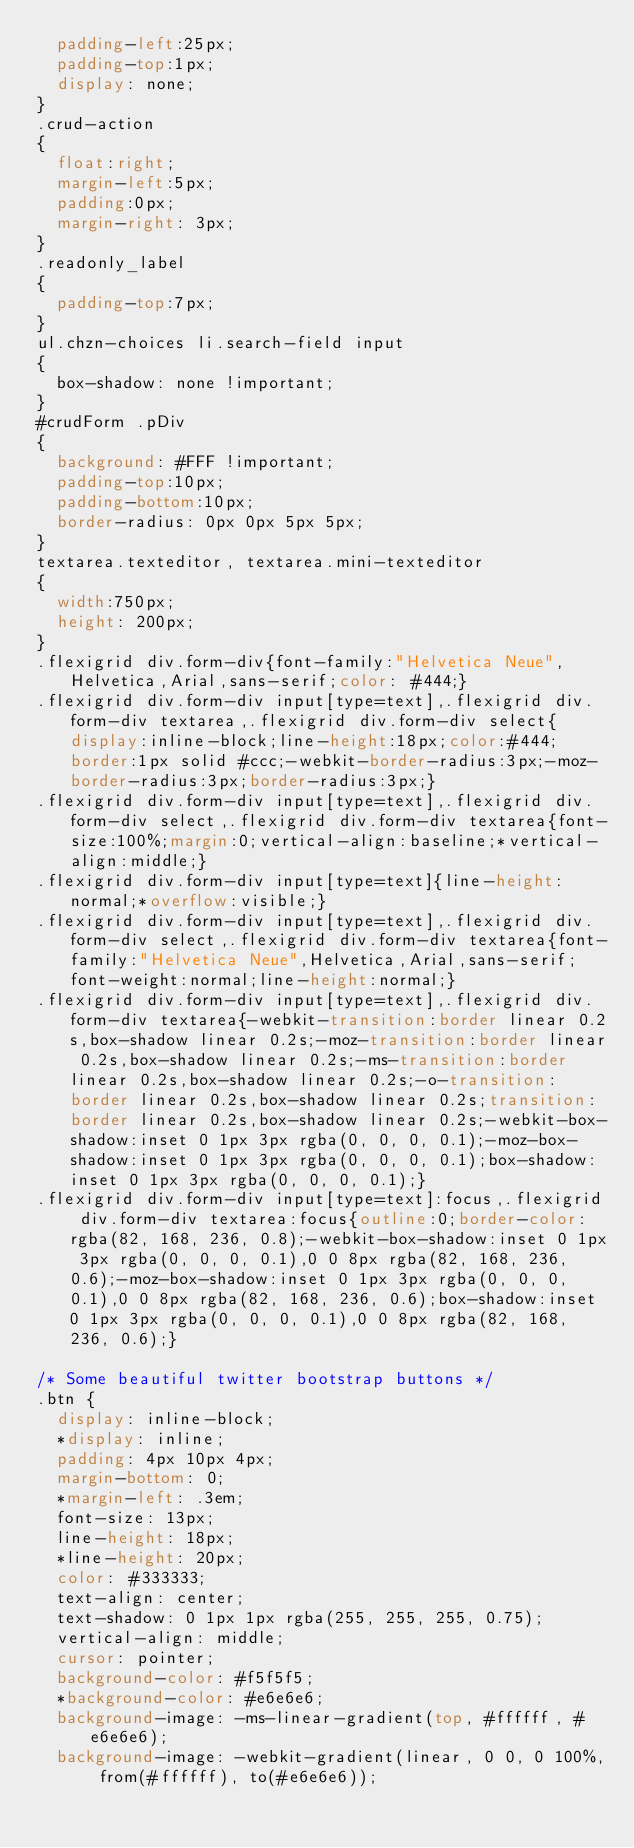Convert code to text. <code><loc_0><loc_0><loc_500><loc_500><_CSS_>	padding-left:25px;
	padding-top:1px;
	display: none;
}
.crud-action
{
	float:right;
	margin-left:5px;
	padding:0px;
	margin-right: 3px;
}
.readonly_label
{
	padding-top:7px;
}
ul.chzn-choices li.search-field input
{
	box-shadow: none !important;
}
#crudForm .pDiv
{
	background: #FFF !important;
	padding-top:10px;
	padding-bottom:10px;
	border-radius: 0px 0px 5px 5px;
}
textarea.texteditor, textarea.mini-texteditor
{
	width:750px;
	height: 200px;
}
.flexigrid div.form-div{font-family:"Helvetica Neue",Helvetica,Arial,sans-serif;color: #444;}
.flexigrid div.form-div input[type=text],.flexigrid div.form-div textarea,.flexigrid div.form-div select{display:inline-block;line-height:18px;color:#444;border:1px solid #ccc;-webkit-border-radius:3px;-moz-border-radius:3px;border-radius:3px;}
.flexigrid div.form-div input[type=text],.flexigrid div.form-div select,.flexigrid div.form-div textarea{font-size:100%;margin:0;vertical-align:baseline;*vertical-align:middle;}
.flexigrid div.form-div input[type=text]{line-height:normal;*overflow:visible;}
.flexigrid div.form-div input[type=text],.flexigrid div.form-div select,.flexigrid div.form-div textarea{font-family:"Helvetica Neue",Helvetica,Arial,sans-serif;font-weight:normal;line-height:normal;}
.flexigrid div.form-div input[type=text],.flexigrid div.form-div textarea{-webkit-transition:border linear 0.2s,box-shadow linear 0.2s;-moz-transition:border linear 0.2s,box-shadow linear 0.2s;-ms-transition:border linear 0.2s,box-shadow linear 0.2s;-o-transition:border linear 0.2s,box-shadow linear 0.2s;transition:border linear 0.2s,box-shadow linear 0.2s;-webkit-box-shadow:inset 0 1px 3px rgba(0, 0, 0, 0.1);-moz-box-shadow:inset 0 1px 3px rgba(0, 0, 0, 0.1);box-shadow:inset 0 1px 3px rgba(0, 0, 0, 0.1);}
.flexigrid div.form-div input[type=text]:focus,.flexigrid div.form-div textarea:focus{outline:0;border-color:rgba(82, 168, 236, 0.8);-webkit-box-shadow:inset 0 1px 3px rgba(0, 0, 0, 0.1),0 0 8px rgba(82, 168, 236, 0.6);-moz-box-shadow:inset 0 1px 3px rgba(0, 0, 0, 0.1),0 0 8px rgba(82, 168, 236, 0.6);box-shadow:inset 0 1px 3px rgba(0, 0, 0, 0.1),0 0 8px rgba(82, 168, 236, 0.6);}

/* Some beautiful twitter bootstrap buttons */
.btn {
  display: inline-block;
  *display: inline;
  padding: 4px 10px 4px;
  margin-bottom: 0;
  *margin-left: .3em;
  font-size: 13px;
  line-height: 18px;
  *line-height: 20px;
  color: #333333;
  text-align: center;
  text-shadow: 0 1px 1px rgba(255, 255, 255, 0.75);
  vertical-align: middle;
  cursor: pointer;
  background-color: #f5f5f5;
  *background-color: #e6e6e6;
  background-image: -ms-linear-gradient(top, #ffffff, #e6e6e6);
  background-image: -webkit-gradient(linear, 0 0, 0 100%, from(#ffffff), to(#e6e6e6));</code> 